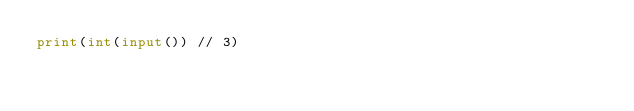<code> <loc_0><loc_0><loc_500><loc_500><_Python_>print(int(input()) // 3)</code> 